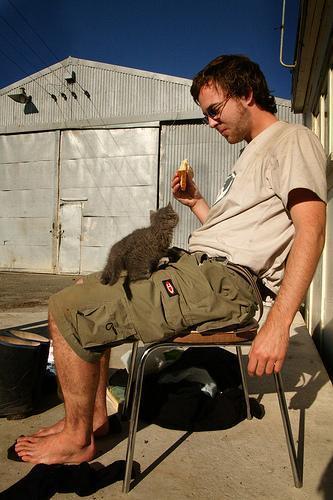How many kittens are in the picture?
Give a very brief answer. 1. How many cats are in the scene?
Give a very brief answer. 1. 